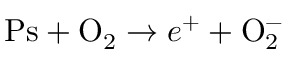<formula> <loc_0><loc_0><loc_500><loc_500>P s + O _ { 2 } \to e ^ { + } + O _ { 2 } ^ { - }</formula> 